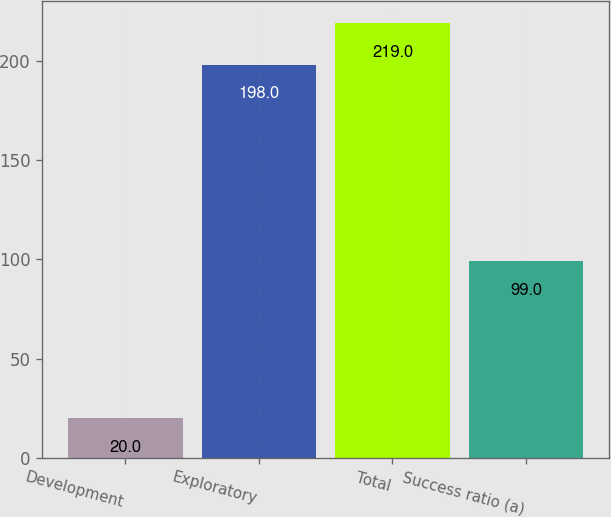<chart> <loc_0><loc_0><loc_500><loc_500><bar_chart><fcel>Development<fcel>Exploratory<fcel>Total<fcel>Success ratio (a)<nl><fcel>20<fcel>198<fcel>219<fcel>99<nl></chart> 